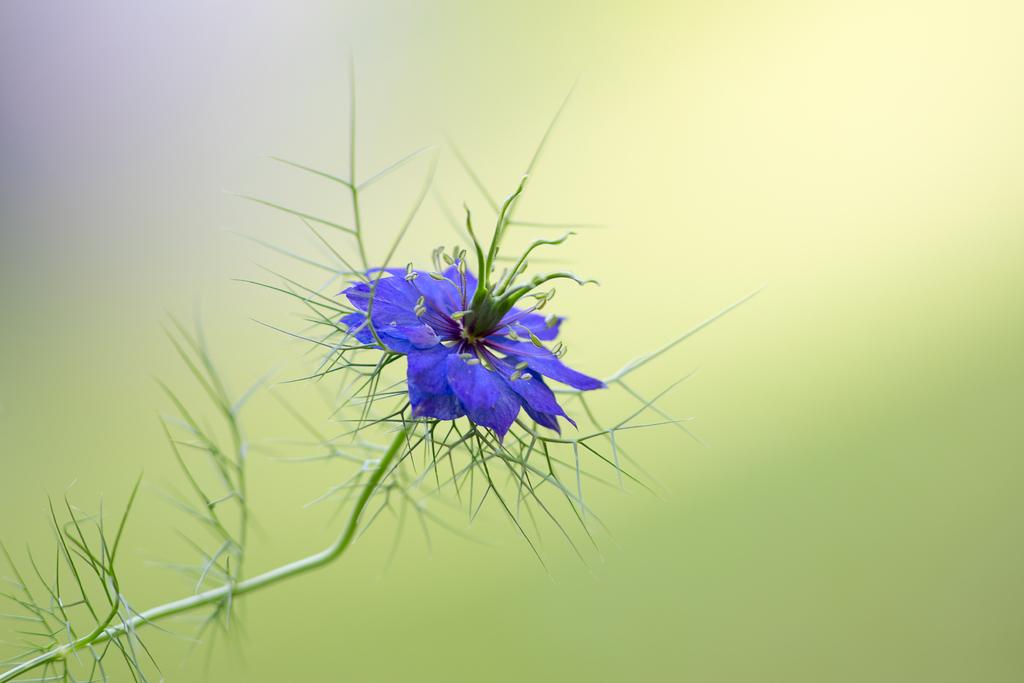What is the main subject of the image? The main subject of the image is a flower. Can you describe the flower in the image? The flower is in violet color. How many bridges can be seen in the image? There are no bridges present in the image; it features a violet flower. What type of instrument is the grandmother playing in the image? There is no grandmother or instrument present in the image. 